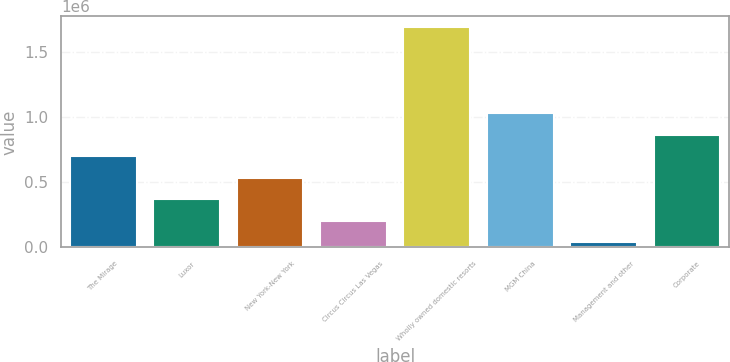<chart> <loc_0><loc_0><loc_500><loc_500><bar_chart><fcel>The Mirage<fcel>Luxor<fcel>New York-New York<fcel>Circus Circus Las Vegas<fcel>Wholly owned domestic resorts<fcel>MGM China<fcel>Management and other<fcel>Corporate<nl><fcel>698438<fcel>367928<fcel>533183<fcel>202674<fcel>1.68997e+06<fcel>1.02895e+06<fcel>37419<fcel>863692<nl></chart> 